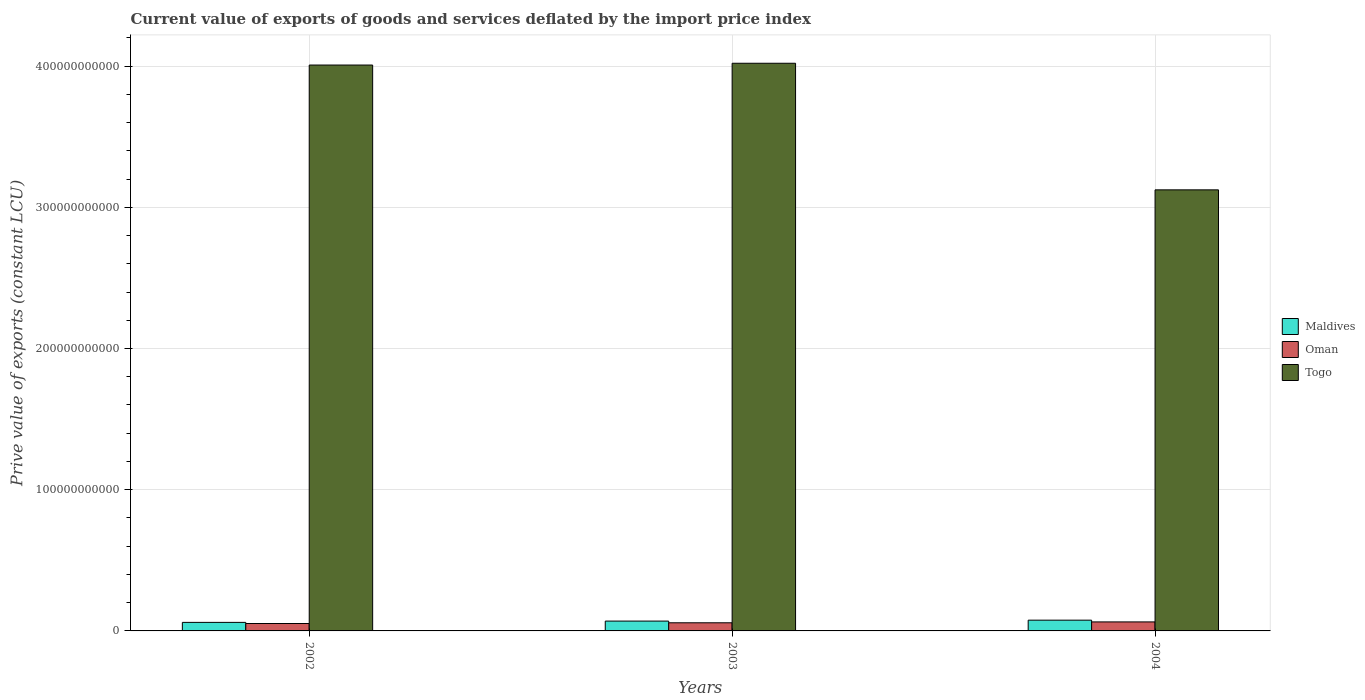How many different coloured bars are there?
Make the answer very short. 3. Are the number of bars on each tick of the X-axis equal?
Your response must be concise. Yes. How many bars are there on the 1st tick from the left?
Offer a terse response. 3. How many bars are there on the 3rd tick from the right?
Your answer should be very brief. 3. In how many cases, is the number of bars for a given year not equal to the number of legend labels?
Make the answer very short. 0. What is the prive value of exports in Togo in 2004?
Keep it short and to the point. 3.12e+11. Across all years, what is the maximum prive value of exports in Oman?
Give a very brief answer. 6.38e+09. Across all years, what is the minimum prive value of exports in Oman?
Your answer should be compact. 5.25e+09. In which year was the prive value of exports in Oman maximum?
Offer a very short reply. 2004. In which year was the prive value of exports in Oman minimum?
Keep it short and to the point. 2002. What is the total prive value of exports in Oman in the graph?
Make the answer very short. 1.74e+1. What is the difference between the prive value of exports in Maldives in 2003 and that in 2004?
Keep it short and to the point. -6.47e+08. What is the difference between the prive value of exports in Togo in 2003 and the prive value of exports in Maldives in 2004?
Offer a terse response. 3.94e+11. What is the average prive value of exports in Togo per year?
Give a very brief answer. 3.72e+11. In the year 2004, what is the difference between the prive value of exports in Maldives and prive value of exports in Oman?
Make the answer very short. 1.23e+09. In how many years, is the prive value of exports in Maldives greater than 380000000000 LCU?
Provide a succinct answer. 0. What is the ratio of the prive value of exports in Maldives in 2002 to that in 2003?
Ensure brevity in your answer.  0.87. Is the difference between the prive value of exports in Maldives in 2003 and 2004 greater than the difference between the prive value of exports in Oman in 2003 and 2004?
Give a very brief answer. No. What is the difference between the highest and the second highest prive value of exports in Maldives?
Give a very brief answer. 6.47e+08. What is the difference between the highest and the lowest prive value of exports in Maldives?
Make the answer very short. 1.57e+09. In how many years, is the prive value of exports in Togo greater than the average prive value of exports in Togo taken over all years?
Make the answer very short. 2. Is the sum of the prive value of exports in Togo in 2002 and 2003 greater than the maximum prive value of exports in Maldives across all years?
Offer a very short reply. Yes. What does the 2nd bar from the left in 2004 represents?
Give a very brief answer. Oman. What does the 2nd bar from the right in 2004 represents?
Offer a very short reply. Oman. Is it the case that in every year, the sum of the prive value of exports in Oman and prive value of exports in Togo is greater than the prive value of exports in Maldives?
Keep it short and to the point. Yes. How many bars are there?
Make the answer very short. 9. Are all the bars in the graph horizontal?
Your answer should be very brief. No. What is the difference between two consecutive major ticks on the Y-axis?
Provide a short and direct response. 1.00e+11. Are the values on the major ticks of Y-axis written in scientific E-notation?
Give a very brief answer. No. Where does the legend appear in the graph?
Provide a succinct answer. Center right. How many legend labels are there?
Give a very brief answer. 3. What is the title of the graph?
Keep it short and to the point. Current value of exports of goods and services deflated by the import price index. What is the label or title of the Y-axis?
Keep it short and to the point. Prive value of exports (constant LCU). What is the Prive value of exports (constant LCU) in Maldives in 2002?
Your response must be concise. 6.05e+09. What is the Prive value of exports (constant LCU) of Oman in 2002?
Ensure brevity in your answer.  5.25e+09. What is the Prive value of exports (constant LCU) of Togo in 2002?
Give a very brief answer. 4.01e+11. What is the Prive value of exports (constant LCU) of Maldives in 2003?
Your answer should be very brief. 6.97e+09. What is the Prive value of exports (constant LCU) of Oman in 2003?
Keep it short and to the point. 5.76e+09. What is the Prive value of exports (constant LCU) in Togo in 2003?
Your answer should be very brief. 4.02e+11. What is the Prive value of exports (constant LCU) in Maldives in 2004?
Your response must be concise. 7.61e+09. What is the Prive value of exports (constant LCU) in Oman in 2004?
Make the answer very short. 6.38e+09. What is the Prive value of exports (constant LCU) in Togo in 2004?
Give a very brief answer. 3.12e+11. Across all years, what is the maximum Prive value of exports (constant LCU) of Maldives?
Offer a terse response. 7.61e+09. Across all years, what is the maximum Prive value of exports (constant LCU) of Oman?
Provide a succinct answer. 6.38e+09. Across all years, what is the maximum Prive value of exports (constant LCU) of Togo?
Ensure brevity in your answer.  4.02e+11. Across all years, what is the minimum Prive value of exports (constant LCU) in Maldives?
Provide a succinct answer. 6.05e+09. Across all years, what is the minimum Prive value of exports (constant LCU) of Oman?
Give a very brief answer. 5.25e+09. Across all years, what is the minimum Prive value of exports (constant LCU) of Togo?
Your answer should be very brief. 3.12e+11. What is the total Prive value of exports (constant LCU) in Maldives in the graph?
Give a very brief answer. 2.06e+1. What is the total Prive value of exports (constant LCU) in Oman in the graph?
Offer a very short reply. 1.74e+1. What is the total Prive value of exports (constant LCU) of Togo in the graph?
Offer a terse response. 1.12e+12. What is the difference between the Prive value of exports (constant LCU) in Maldives in 2002 and that in 2003?
Keep it short and to the point. -9.20e+08. What is the difference between the Prive value of exports (constant LCU) of Oman in 2002 and that in 2003?
Offer a very short reply. -5.11e+08. What is the difference between the Prive value of exports (constant LCU) of Togo in 2002 and that in 2003?
Your answer should be compact. -1.26e+09. What is the difference between the Prive value of exports (constant LCU) in Maldives in 2002 and that in 2004?
Your answer should be very brief. -1.57e+09. What is the difference between the Prive value of exports (constant LCU) in Oman in 2002 and that in 2004?
Provide a short and direct response. -1.13e+09. What is the difference between the Prive value of exports (constant LCU) of Togo in 2002 and that in 2004?
Your response must be concise. 8.84e+1. What is the difference between the Prive value of exports (constant LCU) in Maldives in 2003 and that in 2004?
Give a very brief answer. -6.47e+08. What is the difference between the Prive value of exports (constant LCU) of Oman in 2003 and that in 2004?
Make the answer very short. -6.16e+08. What is the difference between the Prive value of exports (constant LCU) in Togo in 2003 and that in 2004?
Provide a succinct answer. 8.96e+1. What is the difference between the Prive value of exports (constant LCU) in Maldives in 2002 and the Prive value of exports (constant LCU) in Oman in 2003?
Offer a terse response. 2.84e+08. What is the difference between the Prive value of exports (constant LCU) in Maldives in 2002 and the Prive value of exports (constant LCU) in Togo in 2003?
Your answer should be compact. -3.96e+11. What is the difference between the Prive value of exports (constant LCU) in Oman in 2002 and the Prive value of exports (constant LCU) in Togo in 2003?
Your answer should be very brief. -3.97e+11. What is the difference between the Prive value of exports (constant LCU) of Maldives in 2002 and the Prive value of exports (constant LCU) of Oman in 2004?
Offer a terse response. -3.32e+08. What is the difference between the Prive value of exports (constant LCU) of Maldives in 2002 and the Prive value of exports (constant LCU) of Togo in 2004?
Ensure brevity in your answer.  -3.06e+11. What is the difference between the Prive value of exports (constant LCU) of Oman in 2002 and the Prive value of exports (constant LCU) of Togo in 2004?
Offer a terse response. -3.07e+11. What is the difference between the Prive value of exports (constant LCU) of Maldives in 2003 and the Prive value of exports (constant LCU) of Oman in 2004?
Give a very brief answer. 5.87e+08. What is the difference between the Prive value of exports (constant LCU) in Maldives in 2003 and the Prive value of exports (constant LCU) in Togo in 2004?
Ensure brevity in your answer.  -3.05e+11. What is the difference between the Prive value of exports (constant LCU) in Oman in 2003 and the Prive value of exports (constant LCU) in Togo in 2004?
Give a very brief answer. -3.07e+11. What is the average Prive value of exports (constant LCU) in Maldives per year?
Provide a succinct answer. 6.88e+09. What is the average Prive value of exports (constant LCU) of Oman per year?
Make the answer very short. 5.80e+09. What is the average Prive value of exports (constant LCU) in Togo per year?
Give a very brief answer. 3.72e+11. In the year 2002, what is the difference between the Prive value of exports (constant LCU) in Maldives and Prive value of exports (constant LCU) in Oman?
Offer a terse response. 7.95e+08. In the year 2002, what is the difference between the Prive value of exports (constant LCU) of Maldives and Prive value of exports (constant LCU) of Togo?
Offer a terse response. -3.95e+11. In the year 2002, what is the difference between the Prive value of exports (constant LCU) of Oman and Prive value of exports (constant LCU) of Togo?
Offer a very short reply. -3.95e+11. In the year 2003, what is the difference between the Prive value of exports (constant LCU) of Maldives and Prive value of exports (constant LCU) of Oman?
Give a very brief answer. 1.20e+09. In the year 2003, what is the difference between the Prive value of exports (constant LCU) of Maldives and Prive value of exports (constant LCU) of Togo?
Ensure brevity in your answer.  -3.95e+11. In the year 2003, what is the difference between the Prive value of exports (constant LCU) of Oman and Prive value of exports (constant LCU) of Togo?
Your answer should be very brief. -3.96e+11. In the year 2004, what is the difference between the Prive value of exports (constant LCU) of Maldives and Prive value of exports (constant LCU) of Oman?
Your answer should be compact. 1.23e+09. In the year 2004, what is the difference between the Prive value of exports (constant LCU) in Maldives and Prive value of exports (constant LCU) in Togo?
Give a very brief answer. -3.05e+11. In the year 2004, what is the difference between the Prive value of exports (constant LCU) in Oman and Prive value of exports (constant LCU) in Togo?
Keep it short and to the point. -3.06e+11. What is the ratio of the Prive value of exports (constant LCU) in Maldives in 2002 to that in 2003?
Offer a terse response. 0.87. What is the ratio of the Prive value of exports (constant LCU) of Oman in 2002 to that in 2003?
Your answer should be compact. 0.91. What is the ratio of the Prive value of exports (constant LCU) in Maldives in 2002 to that in 2004?
Ensure brevity in your answer.  0.79. What is the ratio of the Prive value of exports (constant LCU) of Oman in 2002 to that in 2004?
Provide a succinct answer. 0.82. What is the ratio of the Prive value of exports (constant LCU) of Togo in 2002 to that in 2004?
Your response must be concise. 1.28. What is the ratio of the Prive value of exports (constant LCU) of Maldives in 2003 to that in 2004?
Keep it short and to the point. 0.92. What is the ratio of the Prive value of exports (constant LCU) of Oman in 2003 to that in 2004?
Ensure brevity in your answer.  0.9. What is the ratio of the Prive value of exports (constant LCU) of Togo in 2003 to that in 2004?
Make the answer very short. 1.29. What is the difference between the highest and the second highest Prive value of exports (constant LCU) of Maldives?
Your answer should be compact. 6.47e+08. What is the difference between the highest and the second highest Prive value of exports (constant LCU) in Oman?
Make the answer very short. 6.16e+08. What is the difference between the highest and the second highest Prive value of exports (constant LCU) in Togo?
Ensure brevity in your answer.  1.26e+09. What is the difference between the highest and the lowest Prive value of exports (constant LCU) of Maldives?
Ensure brevity in your answer.  1.57e+09. What is the difference between the highest and the lowest Prive value of exports (constant LCU) in Oman?
Provide a succinct answer. 1.13e+09. What is the difference between the highest and the lowest Prive value of exports (constant LCU) of Togo?
Keep it short and to the point. 8.96e+1. 